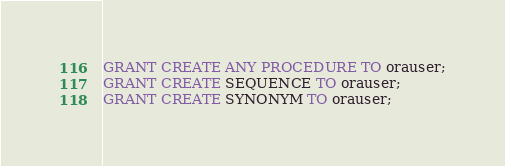Convert code to text. <code><loc_0><loc_0><loc_500><loc_500><_SQL_>GRANT CREATE ANY PROCEDURE TO orauser;
GRANT CREATE SEQUENCE TO orauser;
GRANT CREATE SYNONYM TO orauser;
</code> 